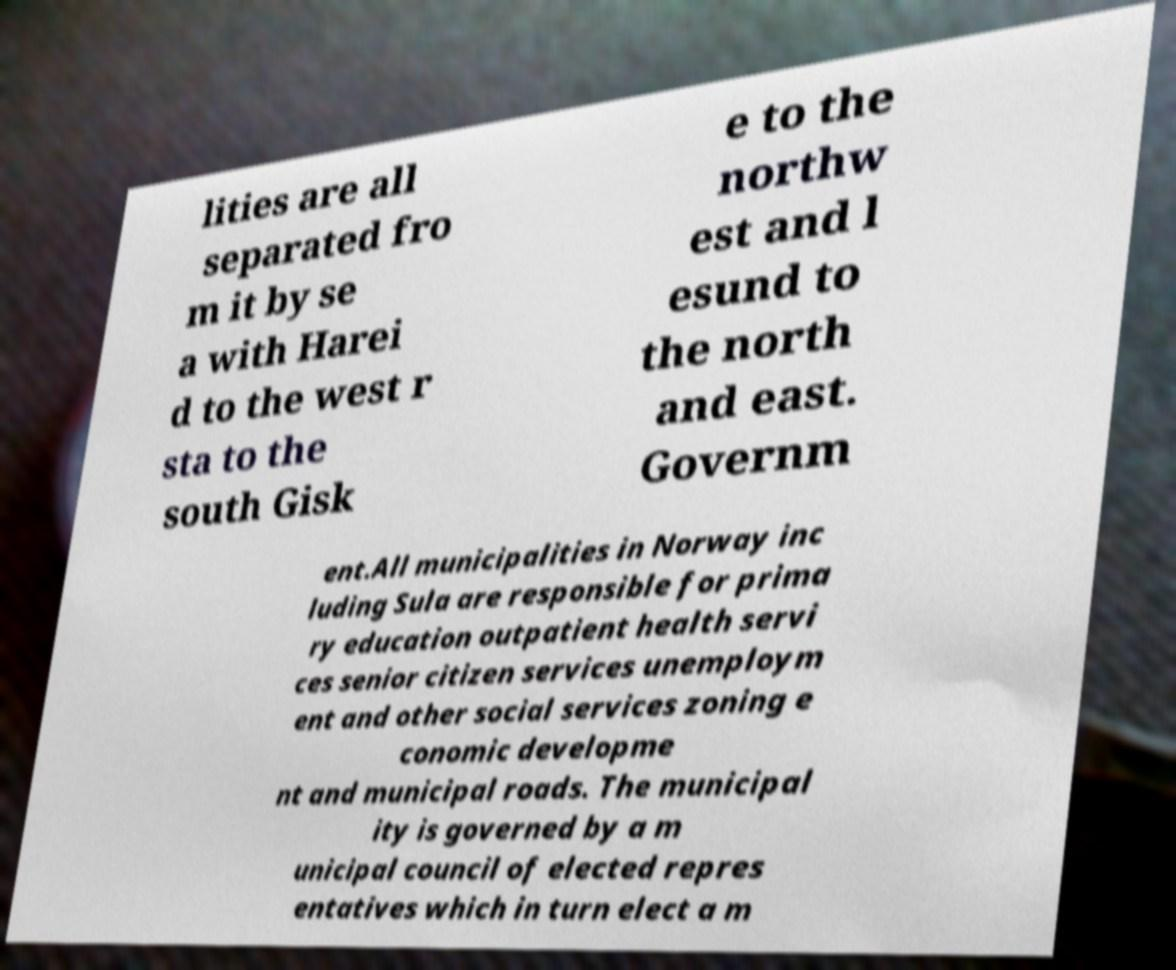Please identify and transcribe the text found in this image. lities are all separated fro m it by se a with Harei d to the west r sta to the south Gisk e to the northw est and l esund to the north and east. Governm ent.All municipalities in Norway inc luding Sula are responsible for prima ry education outpatient health servi ces senior citizen services unemploym ent and other social services zoning e conomic developme nt and municipal roads. The municipal ity is governed by a m unicipal council of elected repres entatives which in turn elect a m 